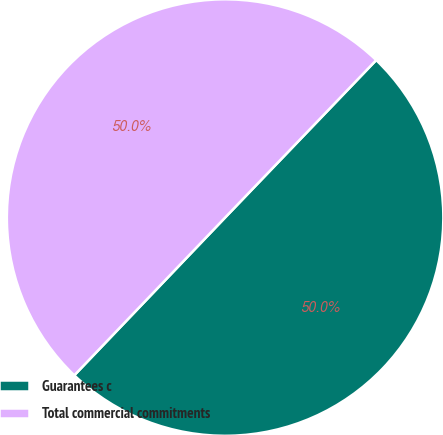<chart> <loc_0><loc_0><loc_500><loc_500><pie_chart><fcel>Guarantees c<fcel>Total commercial commitments<nl><fcel>49.97%<fcel>50.03%<nl></chart> 